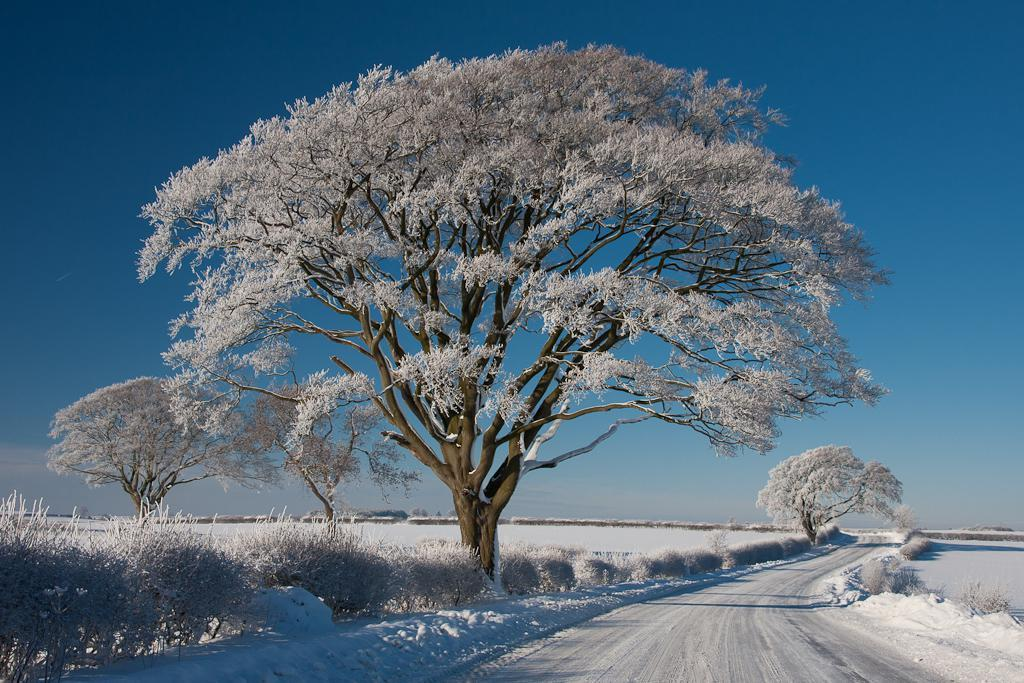What is the condition of the trees and plants in the image? Trees and plants are covered by snow in the image. What can be seen at the bottom of the image? There is a road visible at the bottom of the image. What is the ground covered with in the image? Snow is present on the ground in the image. How many dimes can be seen on the road in the image? There are no dimes visible on the road in the image. Is there a stranger walking along the road in the image? There is no stranger present in the image. 